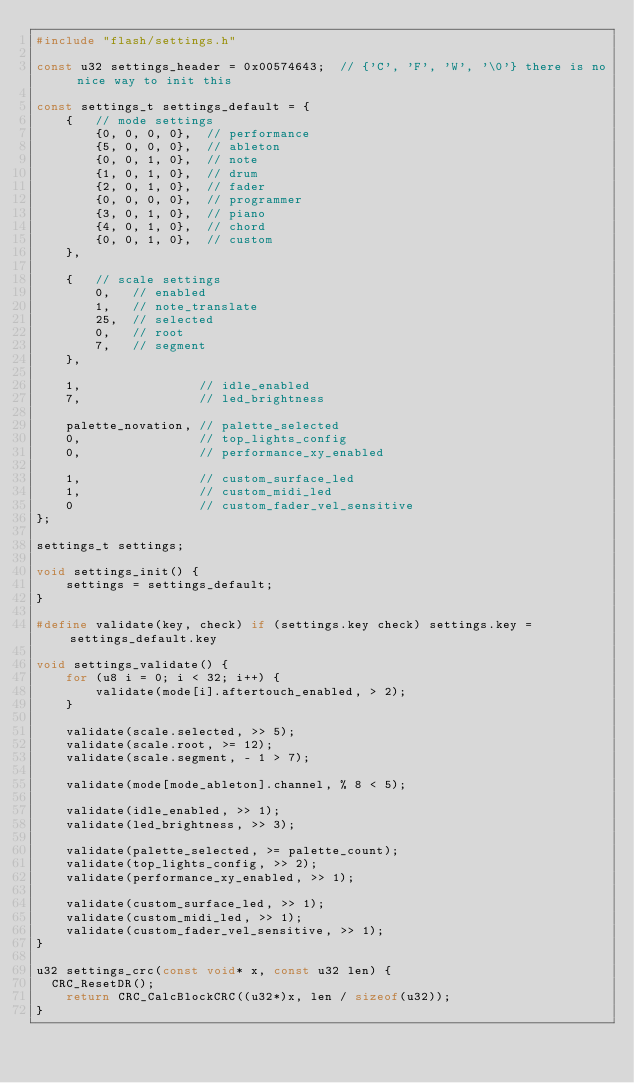Convert code to text. <code><loc_0><loc_0><loc_500><loc_500><_C_>#include "flash/settings.h"

const u32 settings_header = 0x00574643;  // {'C', 'F', 'W', '\0'} there is no nice way to init this

const settings_t settings_default = {
    {   // mode settings
        {0, 0, 0, 0},  // performance
        {5, 0, 0, 0},  // ableton
        {0, 0, 1, 0},  // note
        {1, 0, 1, 0},  // drum
        {2, 0, 1, 0},  // fader
        {0, 0, 0, 0},  // programmer
        {3, 0, 1, 0},  // piano
        {4, 0, 1, 0},  // chord
        {0, 0, 1, 0},  // custom
    },

    {   // scale settings
        0,   // enabled
        1,   // note_translate
        25,  // selected
        0,   // root
        7,   // segment
    },

    1,                // idle_enabled
    7,                // led_brightness

    palette_novation, // palette_selected
    0,                // top_lights_config
    0,                // performance_xy_enabled

    1,                // custom_surface_led
    1,                // custom_midi_led
    0                 // custom_fader_vel_sensitive
};

settings_t settings;

void settings_init() {
    settings = settings_default;
}

#define validate(key, check) if (settings.key check) settings.key = settings_default.key

void settings_validate() {
    for (u8 i = 0; i < 32; i++) {
        validate(mode[i].aftertouch_enabled, > 2);
    }

    validate(scale.selected, >> 5);
    validate(scale.root, >= 12);
    validate(scale.segment, - 1 > 7);

    validate(mode[mode_ableton].channel, % 8 < 5);

    validate(idle_enabled, >> 1);
    validate(led_brightness, >> 3);

    validate(palette_selected, >= palette_count);
    validate(top_lights_config, >> 2);
    validate(performance_xy_enabled, >> 1);

    validate(custom_surface_led, >> 1);
    validate(custom_midi_led, >> 1);
    validate(custom_fader_vel_sensitive, >> 1);
}

u32 settings_crc(const void* x, const u32 len) {
	CRC_ResetDR();
    return CRC_CalcBlockCRC((u32*)x, len / sizeof(u32));
}</code> 